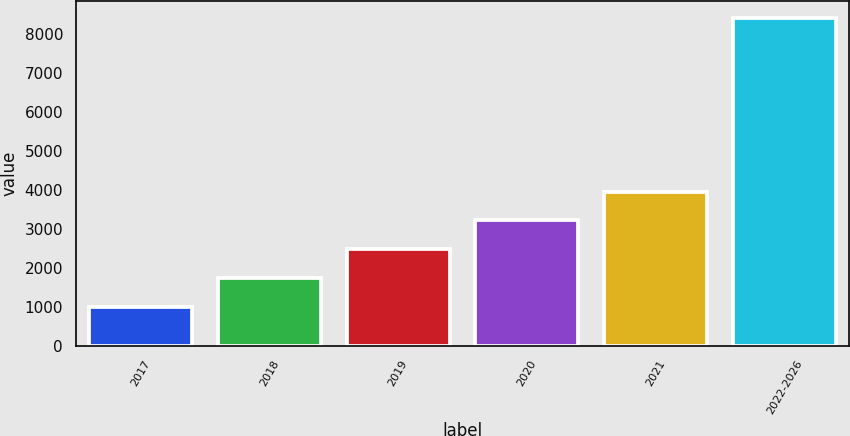<chart> <loc_0><loc_0><loc_500><loc_500><bar_chart><fcel>2017<fcel>2018<fcel>2019<fcel>2020<fcel>2021<fcel>2022-2026<nl><fcel>982<fcel>1726.2<fcel>2470.4<fcel>3214.6<fcel>3958.8<fcel>8424<nl></chart> 